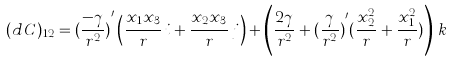Convert formula to latex. <formula><loc_0><loc_0><loc_500><loc_500>( d \, C ) _ { 1 2 } = { ( \frac { - \gamma } { r ^ { 2 } } ) } ^ { \prime } \left ( \frac { x _ { 1 } x _ { 3 } } { r } \, i + \frac { x _ { 2 } x _ { 3 } } { r } \, j \right ) + \left ( \frac { 2 \gamma } { r ^ { 2 } } + { ( \frac { \gamma } { r ^ { 2 } } ) } ^ { \prime } ( \frac { x ^ { 2 } _ { 2 } } { r } + \frac { x ^ { 2 } _ { 1 } } { r } ) \right ) \, k</formula> 